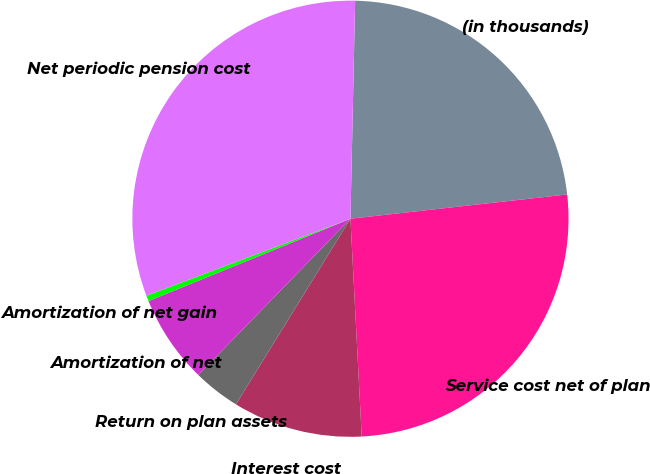<chart> <loc_0><loc_0><loc_500><loc_500><pie_chart><fcel>(in thousands)<fcel>Service cost net of plan<fcel>Interest cost<fcel>Return on plan assets<fcel>Amortization of net<fcel>Amortization of net gain<fcel>Net periodic pension cost<nl><fcel>22.88%<fcel>25.95%<fcel>9.62%<fcel>3.49%<fcel>6.55%<fcel>0.42%<fcel>31.08%<nl></chart> 